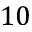Convert formula to latex. <formula><loc_0><loc_0><loc_500><loc_500>1 0</formula> 